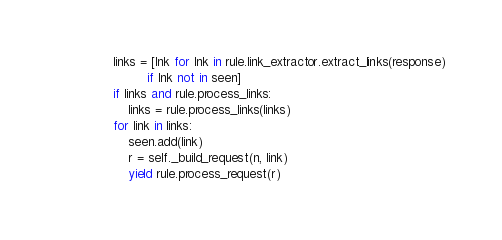<code> <loc_0><loc_0><loc_500><loc_500><_Python_>            links = [lnk for lnk in rule.link_extractor.extract_links(response)
                     if lnk not in seen]
            if links and rule.process_links:
                links = rule.process_links(links)
            for link in links:
                seen.add(link)
                r = self._build_request(n, link)
                yield rule.process_request(r)
</code> 